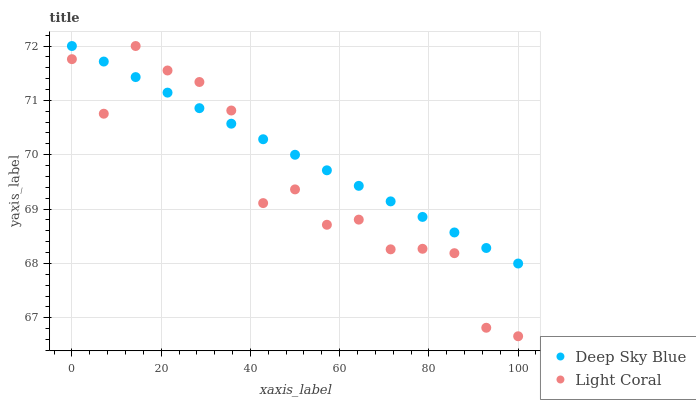Does Light Coral have the minimum area under the curve?
Answer yes or no. Yes. Does Deep Sky Blue have the maximum area under the curve?
Answer yes or no. Yes. Does Deep Sky Blue have the minimum area under the curve?
Answer yes or no. No. Is Deep Sky Blue the smoothest?
Answer yes or no. Yes. Is Light Coral the roughest?
Answer yes or no. Yes. Is Deep Sky Blue the roughest?
Answer yes or no. No. Does Light Coral have the lowest value?
Answer yes or no. Yes. Does Deep Sky Blue have the lowest value?
Answer yes or no. No. Does Deep Sky Blue have the highest value?
Answer yes or no. Yes. Does Deep Sky Blue intersect Light Coral?
Answer yes or no. Yes. Is Deep Sky Blue less than Light Coral?
Answer yes or no. No. Is Deep Sky Blue greater than Light Coral?
Answer yes or no. No. 